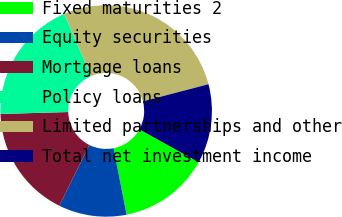Convert chart. <chart><loc_0><loc_0><loc_500><loc_500><pie_chart><fcel>Fixed maturities 2<fcel>Equity securities<fcel>Mortgage loans<fcel>Policy loans<fcel>Limited partnerships and other<fcel>Total net investment income<nl><fcel>13.84%<fcel>10.4%<fcel>17.24%<fcel>18.95%<fcel>27.44%<fcel>12.13%<nl></chart> 